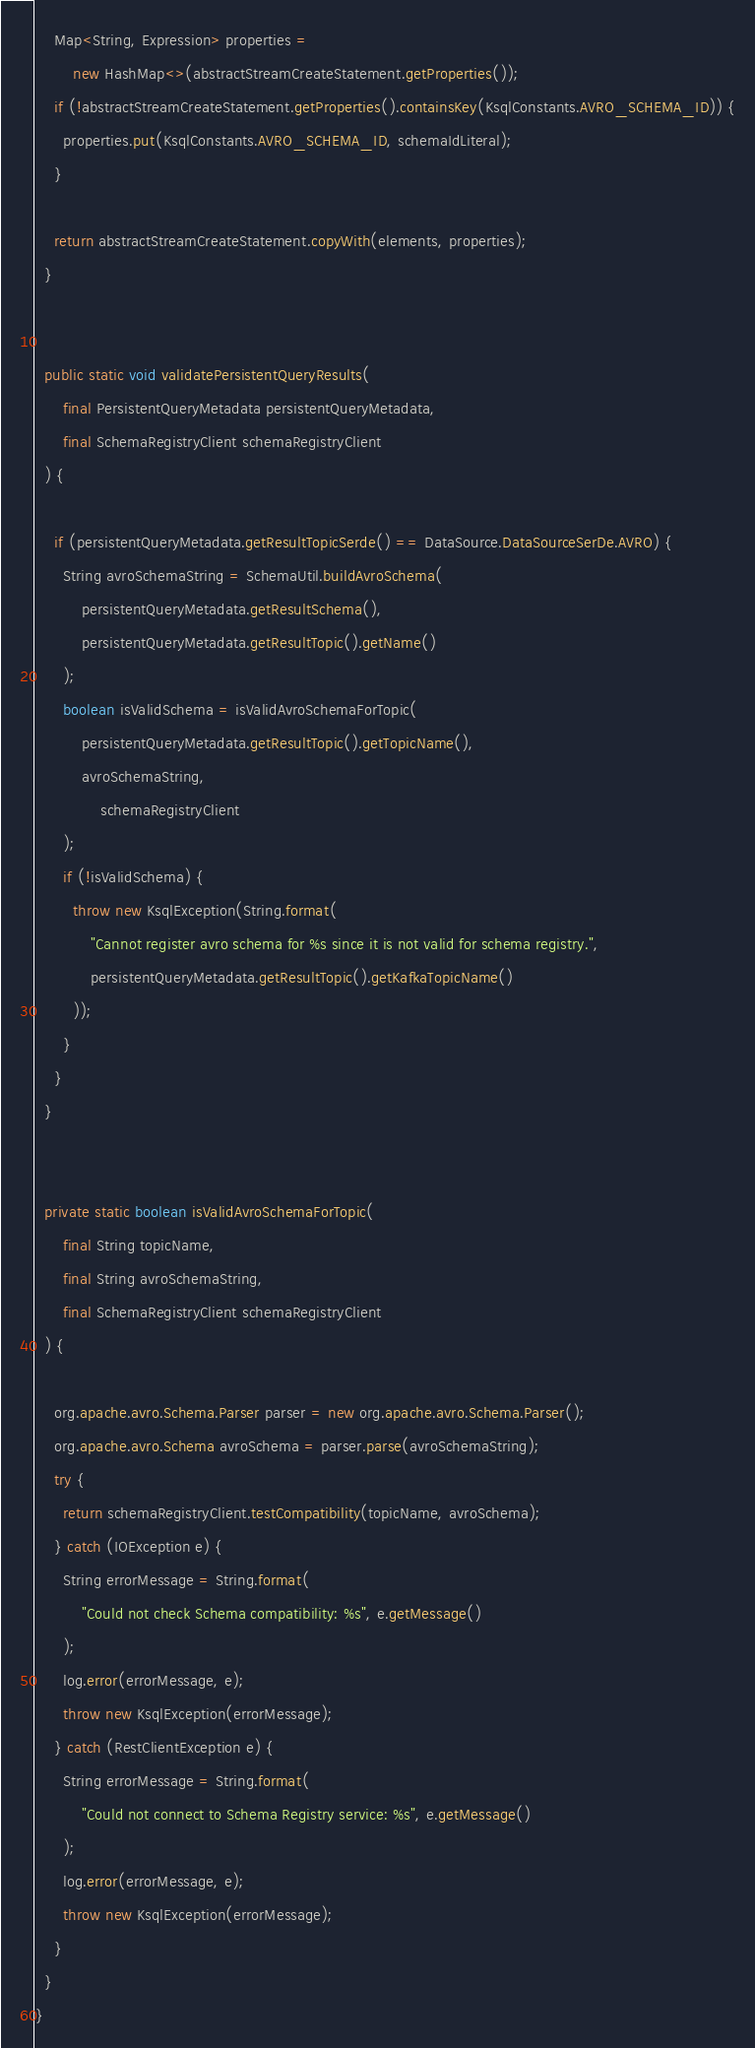<code> <loc_0><loc_0><loc_500><loc_500><_Java_>    Map<String, Expression> properties =
        new HashMap<>(abstractStreamCreateStatement.getProperties());
    if (!abstractStreamCreateStatement.getProperties().containsKey(KsqlConstants.AVRO_SCHEMA_ID)) {
      properties.put(KsqlConstants.AVRO_SCHEMA_ID, schemaIdLiteral);
    }

    return abstractStreamCreateStatement.copyWith(elements, properties);
  }


  public static void validatePersistentQueryResults(
      final PersistentQueryMetadata persistentQueryMetadata,
      final SchemaRegistryClient schemaRegistryClient
  ) {

    if (persistentQueryMetadata.getResultTopicSerde() == DataSource.DataSourceSerDe.AVRO) {
      String avroSchemaString = SchemaUtil.buildAvroSchema(
          persistentQueryMetadata.getResultSchema(),
          persistentQueryMetadata.getResultTopic().getName()
      );
      boolean isValidSchema = isValidAvroSchemaForTopic(
          persistentQueryMetadata.getResultTopic().getTopicName(),
          avroSchemaString,
              schemaRegistryClient
      );
      if (!isValidSchema) {
        throw new KsqlException(String.format(
            "Cannot register avro schema for %s since it is not valid for schema registry.",
            persistentQueryMetadata.getResultTopic().getKafkaTopicName()
        ));
      }
    }
  }


  private static boolean isValidAvroSchemaForTopic(
      final String topicName,
      final String avroSchemaString,
      final SchemaRegistryClient schemaRegistryClient
  ) {

    org.apache.avro.Schema.Parser parser = new org.apache.avro.Schema.Parser();
    org.apache.avro.Schema avroSchema = parser.parse(avroSchemaString);
    try {
      return schemaRegistryClient.testCompatibility(topicName, avroSchema);
    } catch (IOException e) {
      String errorMessage = String.format(
          "Could not check Schema compatibility: %s", e.getMessage()
      );
      log.error(errorMessage, e);
      throw new KsqlException(errorMessage);
    } catch (RestClientException e) {
      String errorMessage = String.format(
          "Could not connect to Schema Registry service: %s", e.getMessage()
      );
      log.error(errorMessage, e);
      throw new KsqlException(errorMessage);
    }
  }
}
</code> 